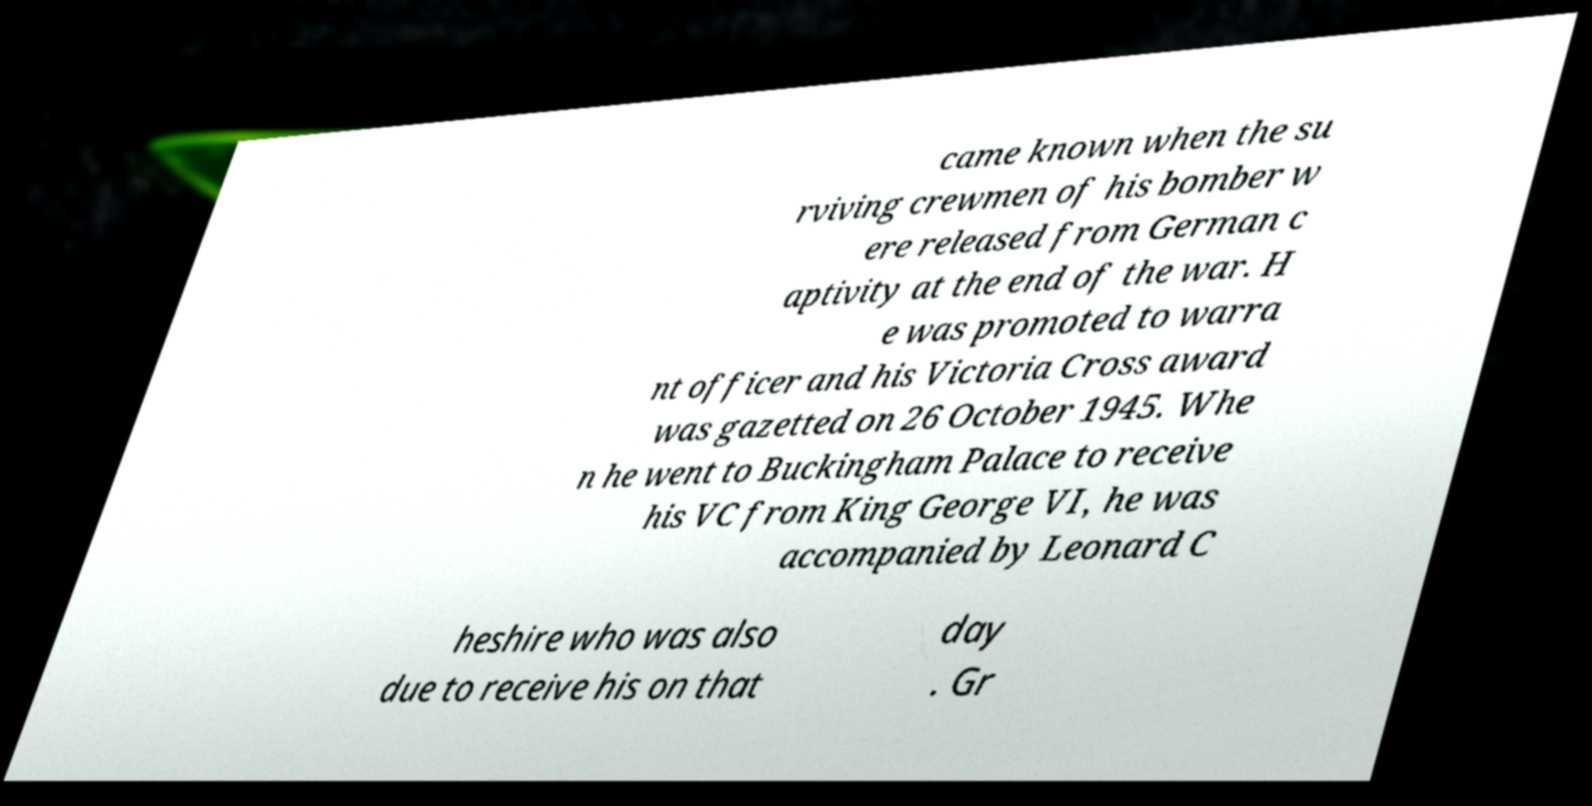Can you read and provide the text displayed in the image?This photo seems to have some interesting text. Can you extract and type it out for me? came known when the su rviving crewmen of his bomber w ere released from German c aptivity at the end of the war. H e was promoted to warra nt officer and his Victoria Cross award was gazetted on 26 October 1945. Whe n he went to Buckingham Palace to receive his VC from King George VI, he was accompanied by Leonard C heshire who was also due to receive his on that day . Gr 